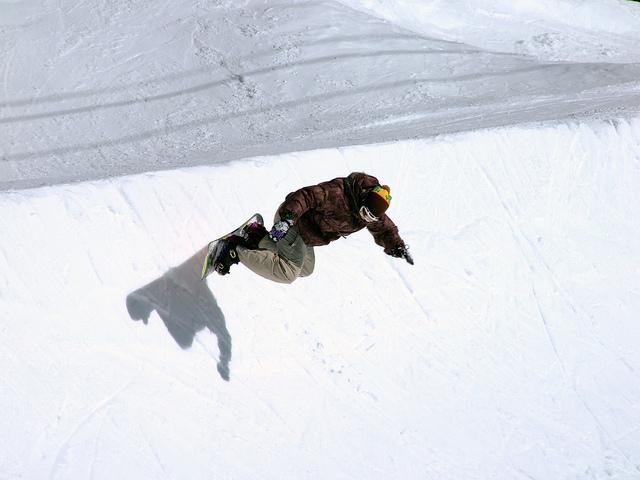Is the snowboarder dressed for the cold weather?
Write a very short answer. Yes. What is the man doing?
Give a very brief answer. Snowboarding. Where is the man at?
Answer briefly. Ski slope. 